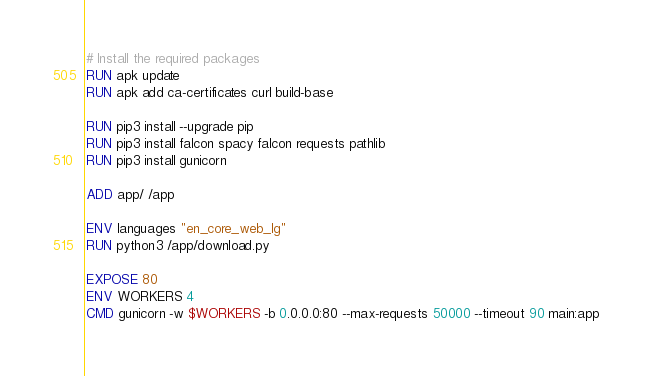<code> <loc_0><loc_0><loc_500><loc_500><_Dockerfile_>
# Install the required packages
RUN apk update
RUN apk add ca-certificates curl build-base

RUN pip3 install --upgrade pip
RUN pip3 install falcon spacy falcon requests pathlib
RUN pip3 install gunicorn

ADD app/ /app

ENV languages "en_core_web_lg"
RUN python3 /app/download.py

EXPOSE 80
ENV WORKERS 4
CMD gunicorn -w $WORKERS -b 0.0.0.0:80 --max-requests 50000 --timeout 90 main:app
</code> 